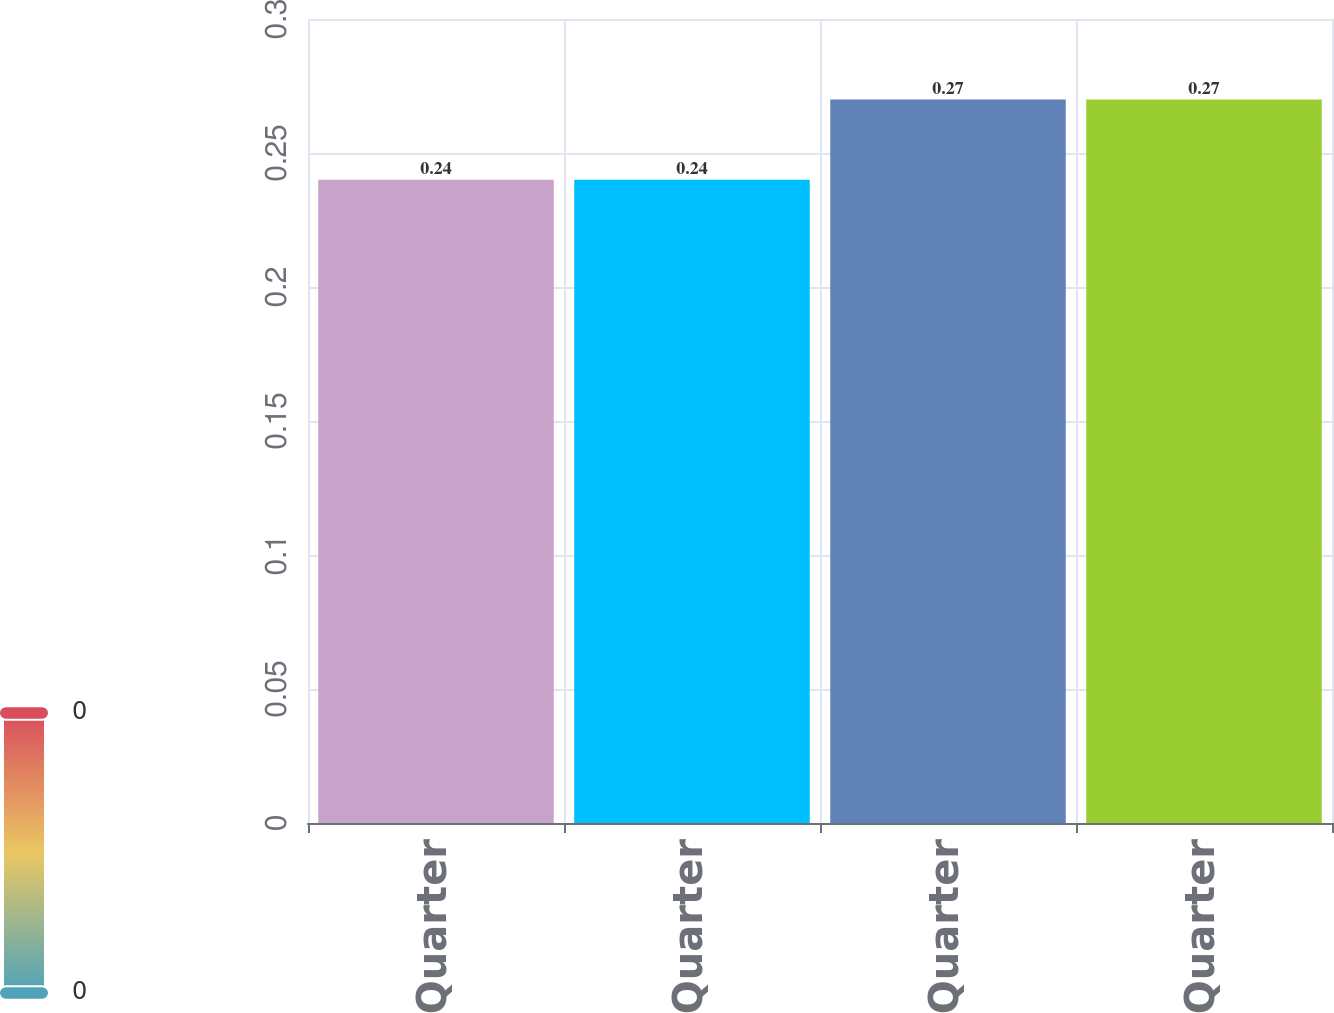<chart> <loc_0><loc_0><loc_500><loc_500><bar_chart><fcel>1st Quarter<fcel>2nd Quarter<fcel>3rd Quarter<fcel>4th Quarter<nl><fcel>0.24<fcel>0.24<fcel>0.27<fcel>0.27<nl></chart> 